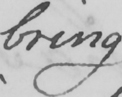Can you read and transcribe this handwriting? bring 